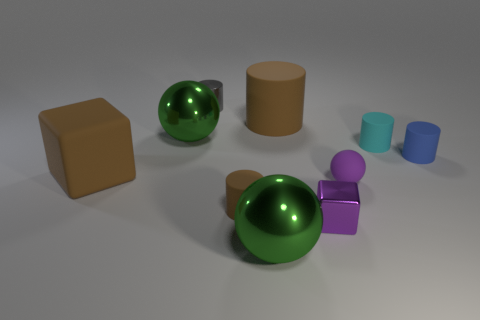Is the number of purple metallic objects left of the small brown thing the same as the number of large blue balls?
Make the answer very short. Yes. What number of cyan objects have the same material as the small sphere?
Provide a short and direct response. 1. Are there fewer small cyan matte objects than tiny things?
Make the answer very short. Yes. There is a ball behind the large rubber block; does it have the same color as the small metal cube?
Offer a very short reply. No. There is a green metal thing that is behind the large sphere that is in front of the blue thing; how many green metal spheres are to the right of it?
Ensure brevity in your answer.  1. What number of green metal balls are to the left of the tiny gray metal cylinder?
Keep it short and to the point. 1. What is the color of the other large thing that is the same shape as the gray object?
Provide a short and direct response. Brown. There is a tiny thing that is both in front of the large brown cube and right of the small block; what is its material?
Provide a short and direct response. Rubber. There is a green sphere that is to the right of the gray shiny thing; does it have the same size as the small blue matte object?
Make the answer very short. No. What material is the cyan cylinder?
Your answer should be very brief. Rubber. 